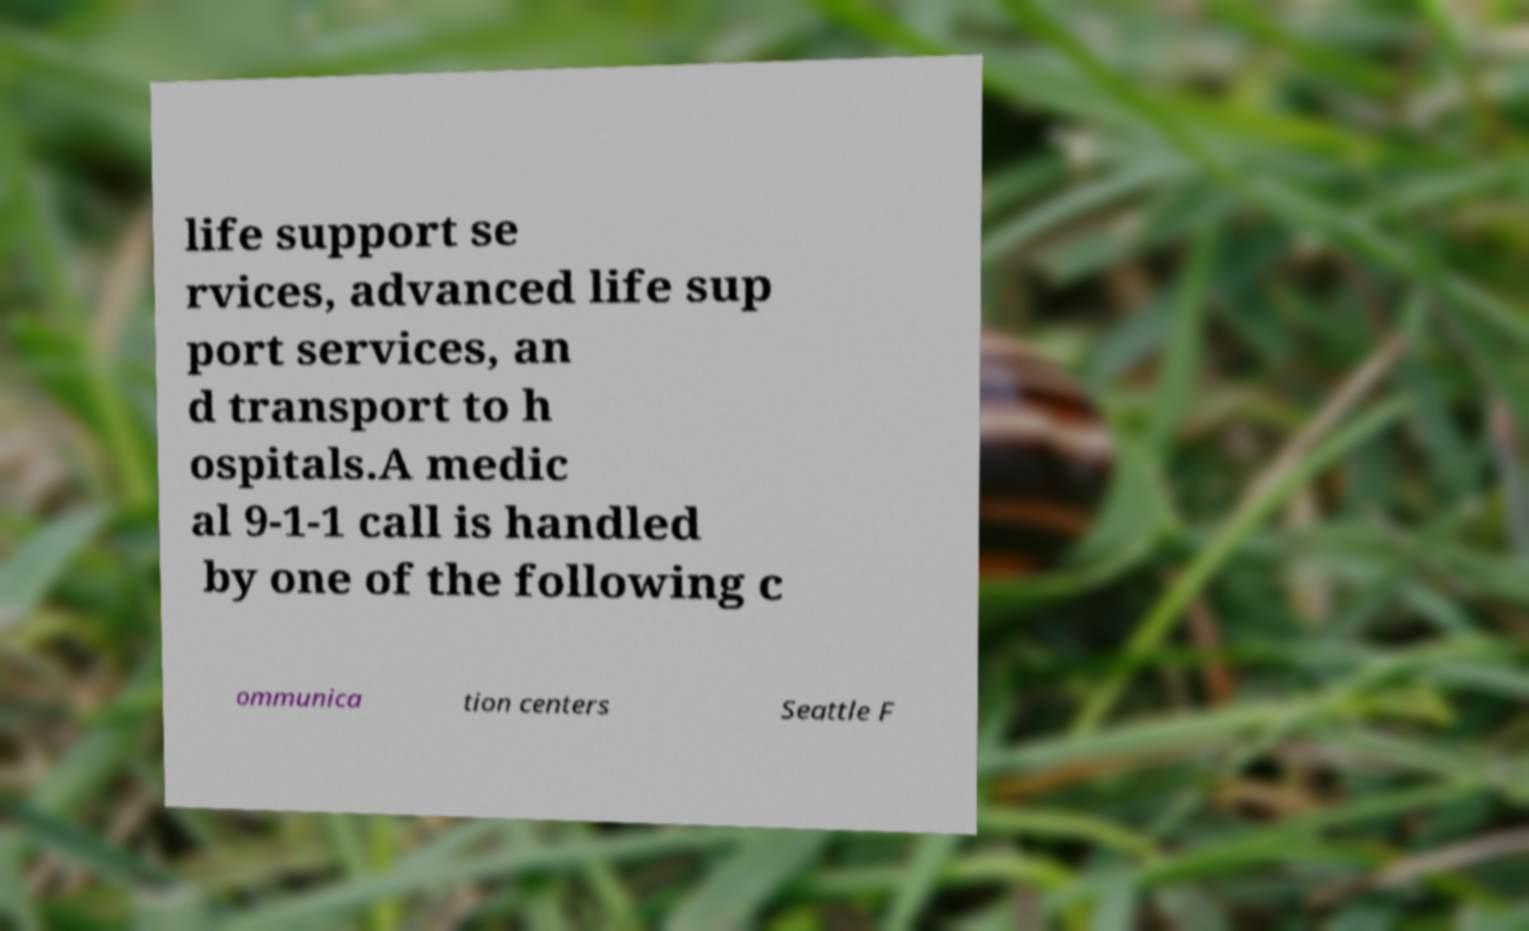For documentation purposes, I need the text within this image transcribed. Could you provide that? life support se rvices, advanced life sup port services, an d transport to h ospitals.A medic al 9-1-1 call is handled by one of the following c ommunica tion centers Seattle F 